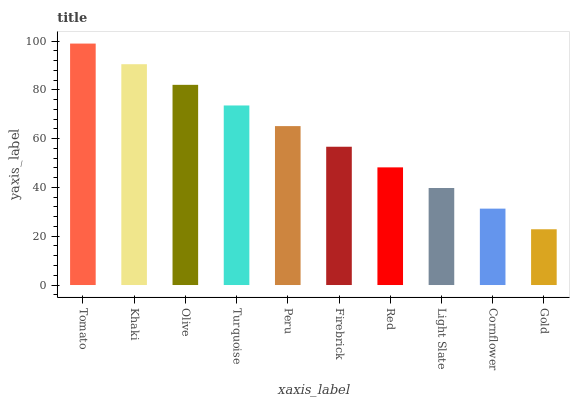Is Gold the minimum?
Answer yes or no. Yes. Is Tomato the maximum?
Answer yes or no. Yes. Is Khaki the minimum?
Answer yes or no. No. Is Khaki the maximum?
Answer yes or no. No. Is Tomato greater than Khaki?
Answer yes or no. Yes. Is Khaki less than Tomato?
Answer yes or no. Yes. Is Khaki greater than Tomato?
Answer yes or no. No. Is Tomato less than Khaki?
Answer yes or no. No. Is Peru the high median?
Answer yes or no. Yes. Is Firebrick the low median?
Answer yes or no. Yes. Is Light Slate the high median?
Answer yes or no. No. Is Cornflower the low median?
Answer yes or no. No. 